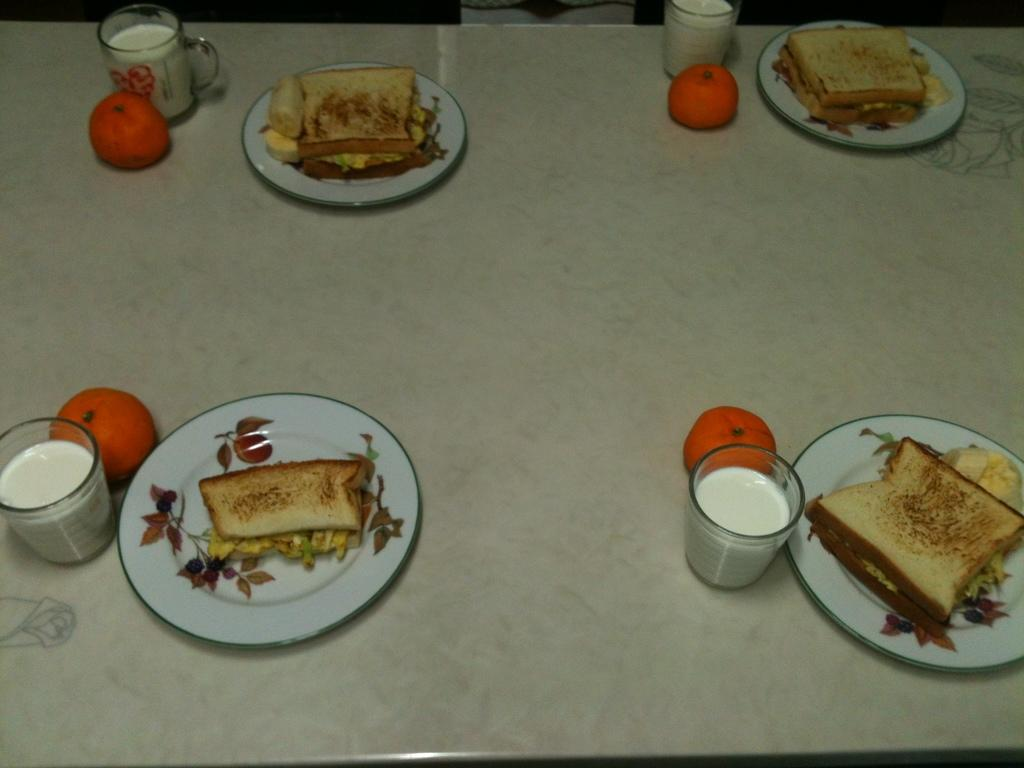What type of furniture is present in the image? There is a dining table in the image. What is placed on the dining table? There are plates with food items and glasses with liquids on the table. What type of fruits can be seen on the table? There are orange-colored fruits on the table. Can you tell me how many bats are hanging from the ceiling in the image? There are no bats present in the image; it features a dining table with plates, glasses, and fruits. What type of clam is being served on the plates in the image? There are no clams visible on the plates in the image; only food items are mentioned. 